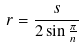Convert formula to latex. <formula><loc_0><loc_0><loc_500><loc_500>r = \frac { s } { 2 \sin \frac { \pi } { n } }</formula> 